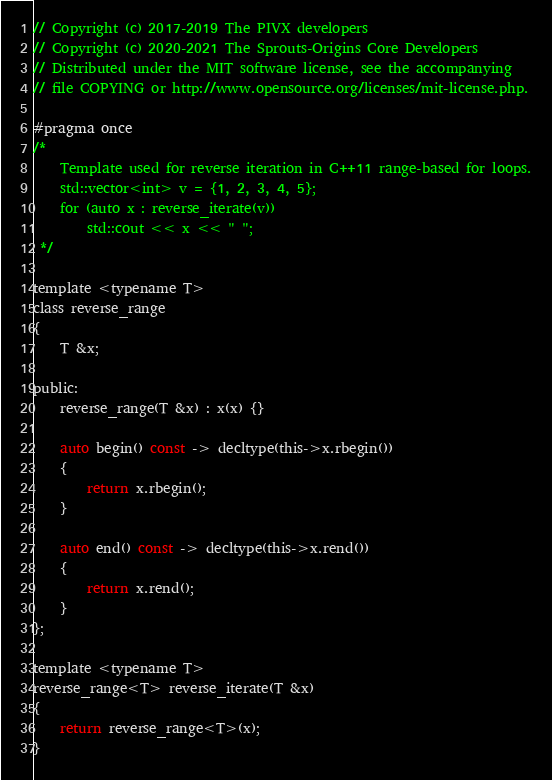Convert code to text. <code><loc_0><loc_0><loc_500><loc_500><_C_>// Copyright (c) 2017-2019 The PIVX developers
// Copyright (c) 2020-2021 The Sprouts-Origins Core Developers
// Distributed under the MIT software license, see the accompanying
// file COPYING or http://www.opensource.org/licenses/mit-license.php.

#pragma once
/*
    Template used for reverse iteration in C++11 range-based for loops.
    std::vector<int> v = {1, 2, 3, 4, 5};
    for (auto x : reverse_iterate(v))
        std::cout << x << " ";
 */

template <typename T>
class reverse_range
{
    T &x;
    
public:
    reverse_range(T &x) : x(x) {}
    
    auto begin() const -> decltype(this->x.rbegin())
    {
        return x.rbegin();
    }
    
    auto end() const -> decltype(this->x.rend())
    {
        return x.rend();
    }
};
 
template <typename T>
reverse_range<T> reverse_iterate(T &x)
{
    return reverse_range<T>(x);
}

</code> 